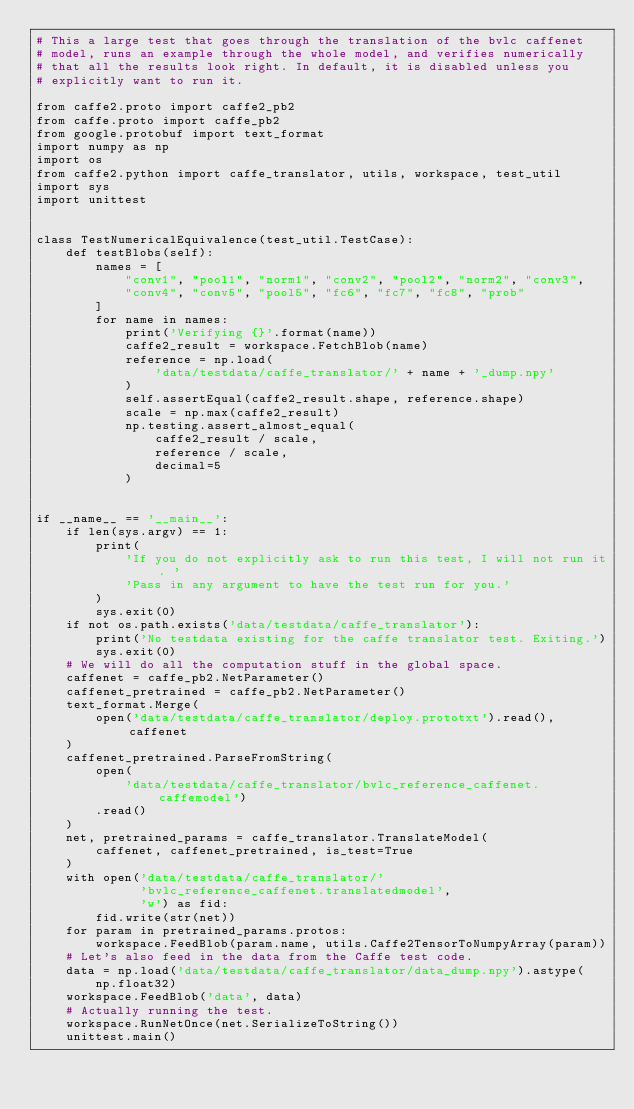<code> <loc_0><loc_0><loc_500><loc_500><_Python_># This a large test that goes through the translation of the bvlc caffenet
# model, runs an example through the whole model, and verifies numerically
# that all the results look right. In default, it is disabled unless you
# explicitly want to run it.

from caffe2.proto import caffe2_pb2
from caffe.proto import caffe_pb2
from google.protobuf import text_format
import numpy as np
import os
from caffe2.python import caffe_translator, utils, workspace, test_util
import sys
import unittest


class TestNumericalEquivalence(test_util.TestCase):
    def testBlobs(self):
        names = [
            "conv1", "pool1", "norm1", "conv2", "pool2", "norm2", "conv3",
            "conv4", "conv5", "pool5", "fc6", "fc7", "fc8", "prob"
        ]
        for name in names:
            print('Verifying {}'.format(name))
            caffe2_result = workspace.FetchBlob(name)
            reference = np.load(
                'data/testdata/caffe_translator/' + name + '_dump.npy'
            )
            self.assertEqual(caffe2_result.shape, reference.shape)
            scale = np.max(caffe2_result)
            np.testing.assert_almost_equal(
                caffe2_result / scale,
                reference / scale,
                decimal=5
            )


if __name__ == '__main__':
    if len(sys.argv) == 1:
        print(
            'If you do not explicitly ask to run this test, I will not run it. '
            'Pass in any argument to have the test run for you.'
        )
        sys.exit(0)
    if not os.path.exists('data/testdata/caffe_translator'):
        print('No testdata existing for the caffe translator test. Exiting.')
        sys.exit(0)
    # We will do all the computation stuff in the global space.
    caffenet = caffe_pb2.NetParameter()
    caffenet_pretrained = caffe_pb2.NetParameter()
    text_format.Merge(
        open('data/testdata/caffe_translator/deploy.prototxt').read(), caffenet
    )
    caffenet_pretrained.ParseFromString(
        open(
            'data/testdata/caffe_translator/bvlc_reference_caffenet.caffemodel')
        .read()
    )
    net, pretrained_params = caffe_translator.TranslateModel(
        caffenet, caffenet_pretrained, is_test=True
    )
    with open('data/testdata/caffe_translator/'
              'bvlc_reference_caffenet.translatedmodel',
              'w') as fid:
        fid.write(str(net))
    for param in pretrained_params.protos:
        workspace.FeedBlob(param.name, utils.Caffe2TensorToNumpyArray(param))
    # Let's also feed in the data from the Caffe test code.
    data = np.load('data/testdata/caffe_translator/data_dump.npy').astype(
        np.float32)
    workspace.FeedBlob('data', data)
    # Actually running the test.
    workspace.RunNetOnce(net.SerializeToString())
    unittest.main()
</code> 